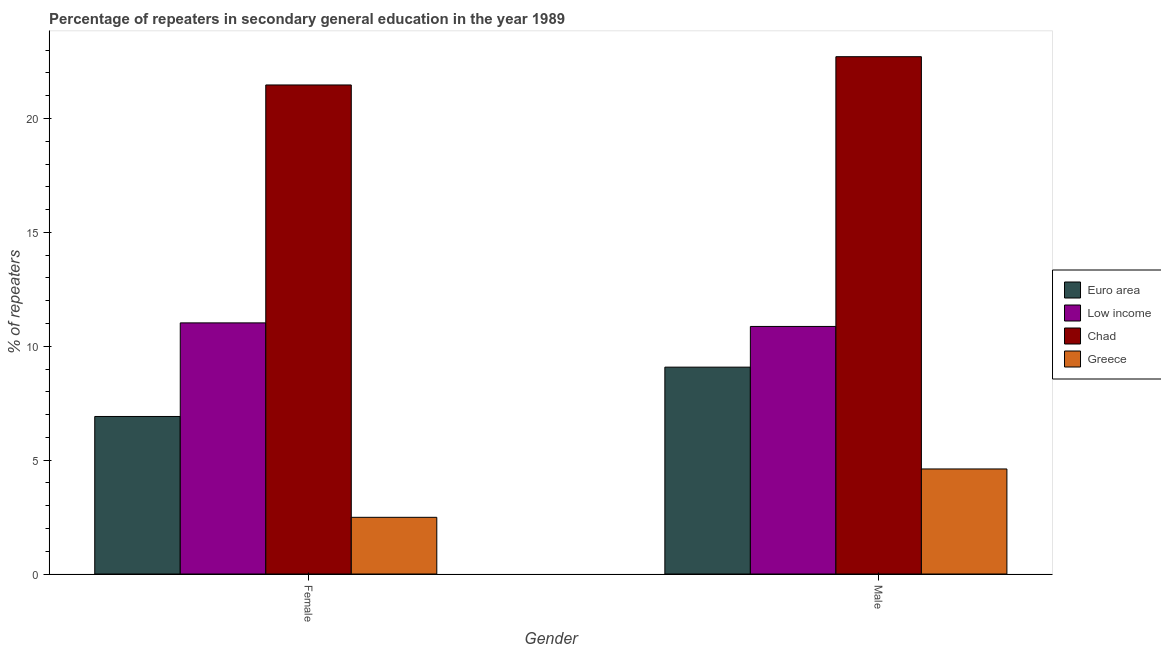Are the number of bars per tick equal to the number of legend labels?
Provide a succinct answer. Yes. How many bars are there on the 1st tick from the left?
Offer a very short reply. 4. How many bars are there on the 2nd tick from the right?
Give a very brief answer. 4. What is the percentage of male repeaters in Low income?
Ensure brevity in your answer.  10.87. Across all countries, what is the maximum percentage of male repeaters?
Your response must be concise. 22.71. Across all countries, what is the minimum percentage of female repeaters?
Offer a very short reply. 2.49. In which country was the percentage of female repeaters maximum?
Your response must be concise. Chad. What is the total percentage of female repeaters in the graph?
Offer a very short reply. 41.9. What is the difference between the percentage of male repeaters in Low income and that in Euro area?
Your answer should be compact. 1.79. What is the difference between the percentage of male repeaters in Greece and the percentage of female repeaters in Chad?
Ensure brevity in your answer.  -16.86. What is the average percentage of female repeaters per country?
Your answer should be compact. 10.47. What is the difference between the percentage of male repeaters and percentage of female repeaters in Low income?
Offer a very short reply. -0.16. In how many countries, is the percentage of female repeaters greater than 16 %?
Keep it short and to the point. 1. What is the ratio of the percentage of female repeaters in Euro area to that in Greece?
Provide a short and direct response. 2.78. Is the percentage of male repeaters in Low income less than that in Euro area?
Ensure brevity in your answer.  No. Are the values on the major ticks of Y-axis written in scientific E-notation?
Provide a succinct answer. No. Does the graph contain any zero values?
Make the answer very short. No. How many legend labels are there?
Your answer should be very brief. 4. How are the legend labels stacked?
Provide a succinct answer. Vertical. What is the title of the graph?
Your answer should be compact. Percentage of repeaters in secondary general education in the year 1989. What is the label or title of the X-axis?
Keep it short and to the point. Gender. What is the label or title of the Y-axis?
Your answer should be very brief. % of repeaters. What is the % of repeaters in Euro area in Female?
Your answer should be very brief. 6.92. What is the % of repeaters in Low income in Female?
Offer a terse response. 11.02. What is the % of repeaters in Chad in Female?
Your answer should be very brief. 21.47. What is the % of repeaters in Greece in Female?
Ensure brevity in your answer.  2.49. What is the % of repeaters of Euro area in Male?
Provide a succinct answer. 9.08. What is the % of repeaters in Low income in Male?
Keep it short and to the point. 10.87. What is the % of repeaters in Chad in Male?
Your response must be concise. 22.71. What is the % of repeaters in Greece in Male?
Your answer should be very brief. 4.61. Across all Gender, what is the maximum % of repeaters of Euro area?
Your answer should be compact. 9.08. Across all Gender, what is the maximum % of repeaters in Low income?
Provide a succinct answer. 11.02. Across all Gender, what is the maximum % of repeaters of Chad?
Give a very brief answer. 22.71. Across all Gender, what is the maximum % of repeaters of Greece?
Provide a short and direct response. 4.61. Across all Gender, what is the minimum % of repeaters of Euro area?
Provide a short and direct response. 6.92. Across all Gender, what is the minimum % of repeaters in Low income?
Offer a very short reply. 10.87. Across all Gender, what is the minimum % of repeaters of Chad?
Provide a succinct answer. 21.47. Across all Gender, what is the minimum % of repeaters in Greece?
Offer a very short reply. 2.49. What is the total % of repeaters of Euro area in the graph?
Give a very brief answer. 16. What is the total % of repeaters of Low income in the graph?
Provide a short and direct response. 21.89. What is the total % of repeaters in Chad in the graph?
Keep it short and to the point. 44.18. What is the total % of repeaters of Greece in the graph?
Make the answer very short. 7.1. What is the difference between the % of repeaters of Euro area in Female and that in Male?
Your answer should be very brief. -2.17. What is the difference between the % of repeaters in Low income in Female and that in Male?
Offer a terse response. 0.16. What is the difference between the % of repeaters in Chad in Female and that in Male?
Keep it short and to the point. -1.24. What is the difference between the % of repeaters of Greece in Female and that in Male?
Give a very brief answer. -2.12. What is the difference between the % of repeaters of Euro area in Female and the % of repeaters of Low income in Male?
Provide a succinct answer. -3.95. What is the difference between the % of repeaters in Euro area in Female and the % of repeaters in Chad in Male?
Your response must be concise. -15.8. What is the difference between the % of repeaters in Euro area in Female and the % of repeaters in Greece in Male?
Your answer should be very brief. 2.3. What is the difference between the % of repeaters in Low income in Female and the % of repeaters in Chad in Male?
Keep it short and to the point. -11.69. What is the difference between the % of repeaters in Low income in Female and the % of repeaters in Greece in Male?
Your response must be concise. 6.41. What is the difference between the % of repeaters of Chad in Female and the % of repeaters of Greece in Male?
Provide a succinct answer. 16.86. What is the average % of repeaters in Euro area per Gender?
Provide a short and direct response. 8. What is the average % of repeaters in Low income per Gender?
Your answer should be very brief. 10.95. What is the average % of repeaters in Chad per Gender?
Ensure brevity in your answer.  22.09. What is the average % of repeaters of Greece per Gender?
Your answer should be compact. 3.55. What is the difference between the % of repeaters of Euro area and % of repeaters of Low income in Female?
Give a very brief answer. -4.11. What is the difference between the % of repeaters in Euro area and % of repeaters in Chad in Female?
Make the answer very short. -14.55. What is the difference between the % of repeaters of Euro area and % of repeaters of Greece in Female?
Offer a very short reply. 4.43. What is the difference between the % of repeaters of Low income and % of repeaters of Chad in Female?
Your answer should be very brief. -10.45. What is the difference between the % of repeaters in Low income and % of repeaters in Greece in Female?
Provide a short and direct response. 8.54. What is the difference between the % of repeaters in Chad and % of repeaters in Greece in Female?
Provide a succinct answer. 18.98. What is the difference between the % of repeaters in Euro area and % of repeaters in Low income in Male?
Ensure brevity in your answer.  -1.79. What is the difference between the % of repeaters in Euro area and % of repeaters in Chad in Male?
Your answer should be compact. -13.63. What is the difference between the % of repeaters in Euro area and % of repeaters in Greece in Male?
Give a very brief answer. 4.47. What is the difference between the % of repeaters in Low income and % of repeaters in Chad in Male?
Provide a short and direct response. -11.84. What is the difference between the % of repeaters of Low income and % of repeaters of Greece in Male?
Give a very brief answer. 6.26. What is the ratio of the % of repeaters of Euro area in Female to that in Male?
Make the answer very short. 0.76. What is the ratio of the % of repeaters in Low income in Female to that in Male?
Make the answer very short. 1.01. What is the ratio of the % of repeaters of Chad in Female to that in Male?
Offer a very short reply. 0.95. What is the ratio of the % of repeaters in Greece in Female to that in Male?
Your response must be concise. 0.54. What is the difference between the highest and the second highest % of repeaters of Euro area?
Your answer should be very brief. 2.17. What is the difference between the highest and the second highest % of repeaters of Low income?
Offer a terse response. 0.16. What is the difference between the highest and the second highest % of repeaters in Chad?
Make the answer very short. 1.24. What is the difference between the highest and the second highest % of repeaters in Greece?
Make the answer very short. 2.12. What is the difference between the highest and the lowest % of repeaters of Euro area?
Your answer should be compact. 2.17. What is the difference between the highest and the lowest % of repeaters of Low income?
Your answer should be compact. 0.16. What is the difference between the highest and the lowest % of repeaters in Chad?
Your response must be concise. 1.24. What is the difference between the highest and the lowest % of repeaters of Greece?
Give a very brief answer. 2.12. 